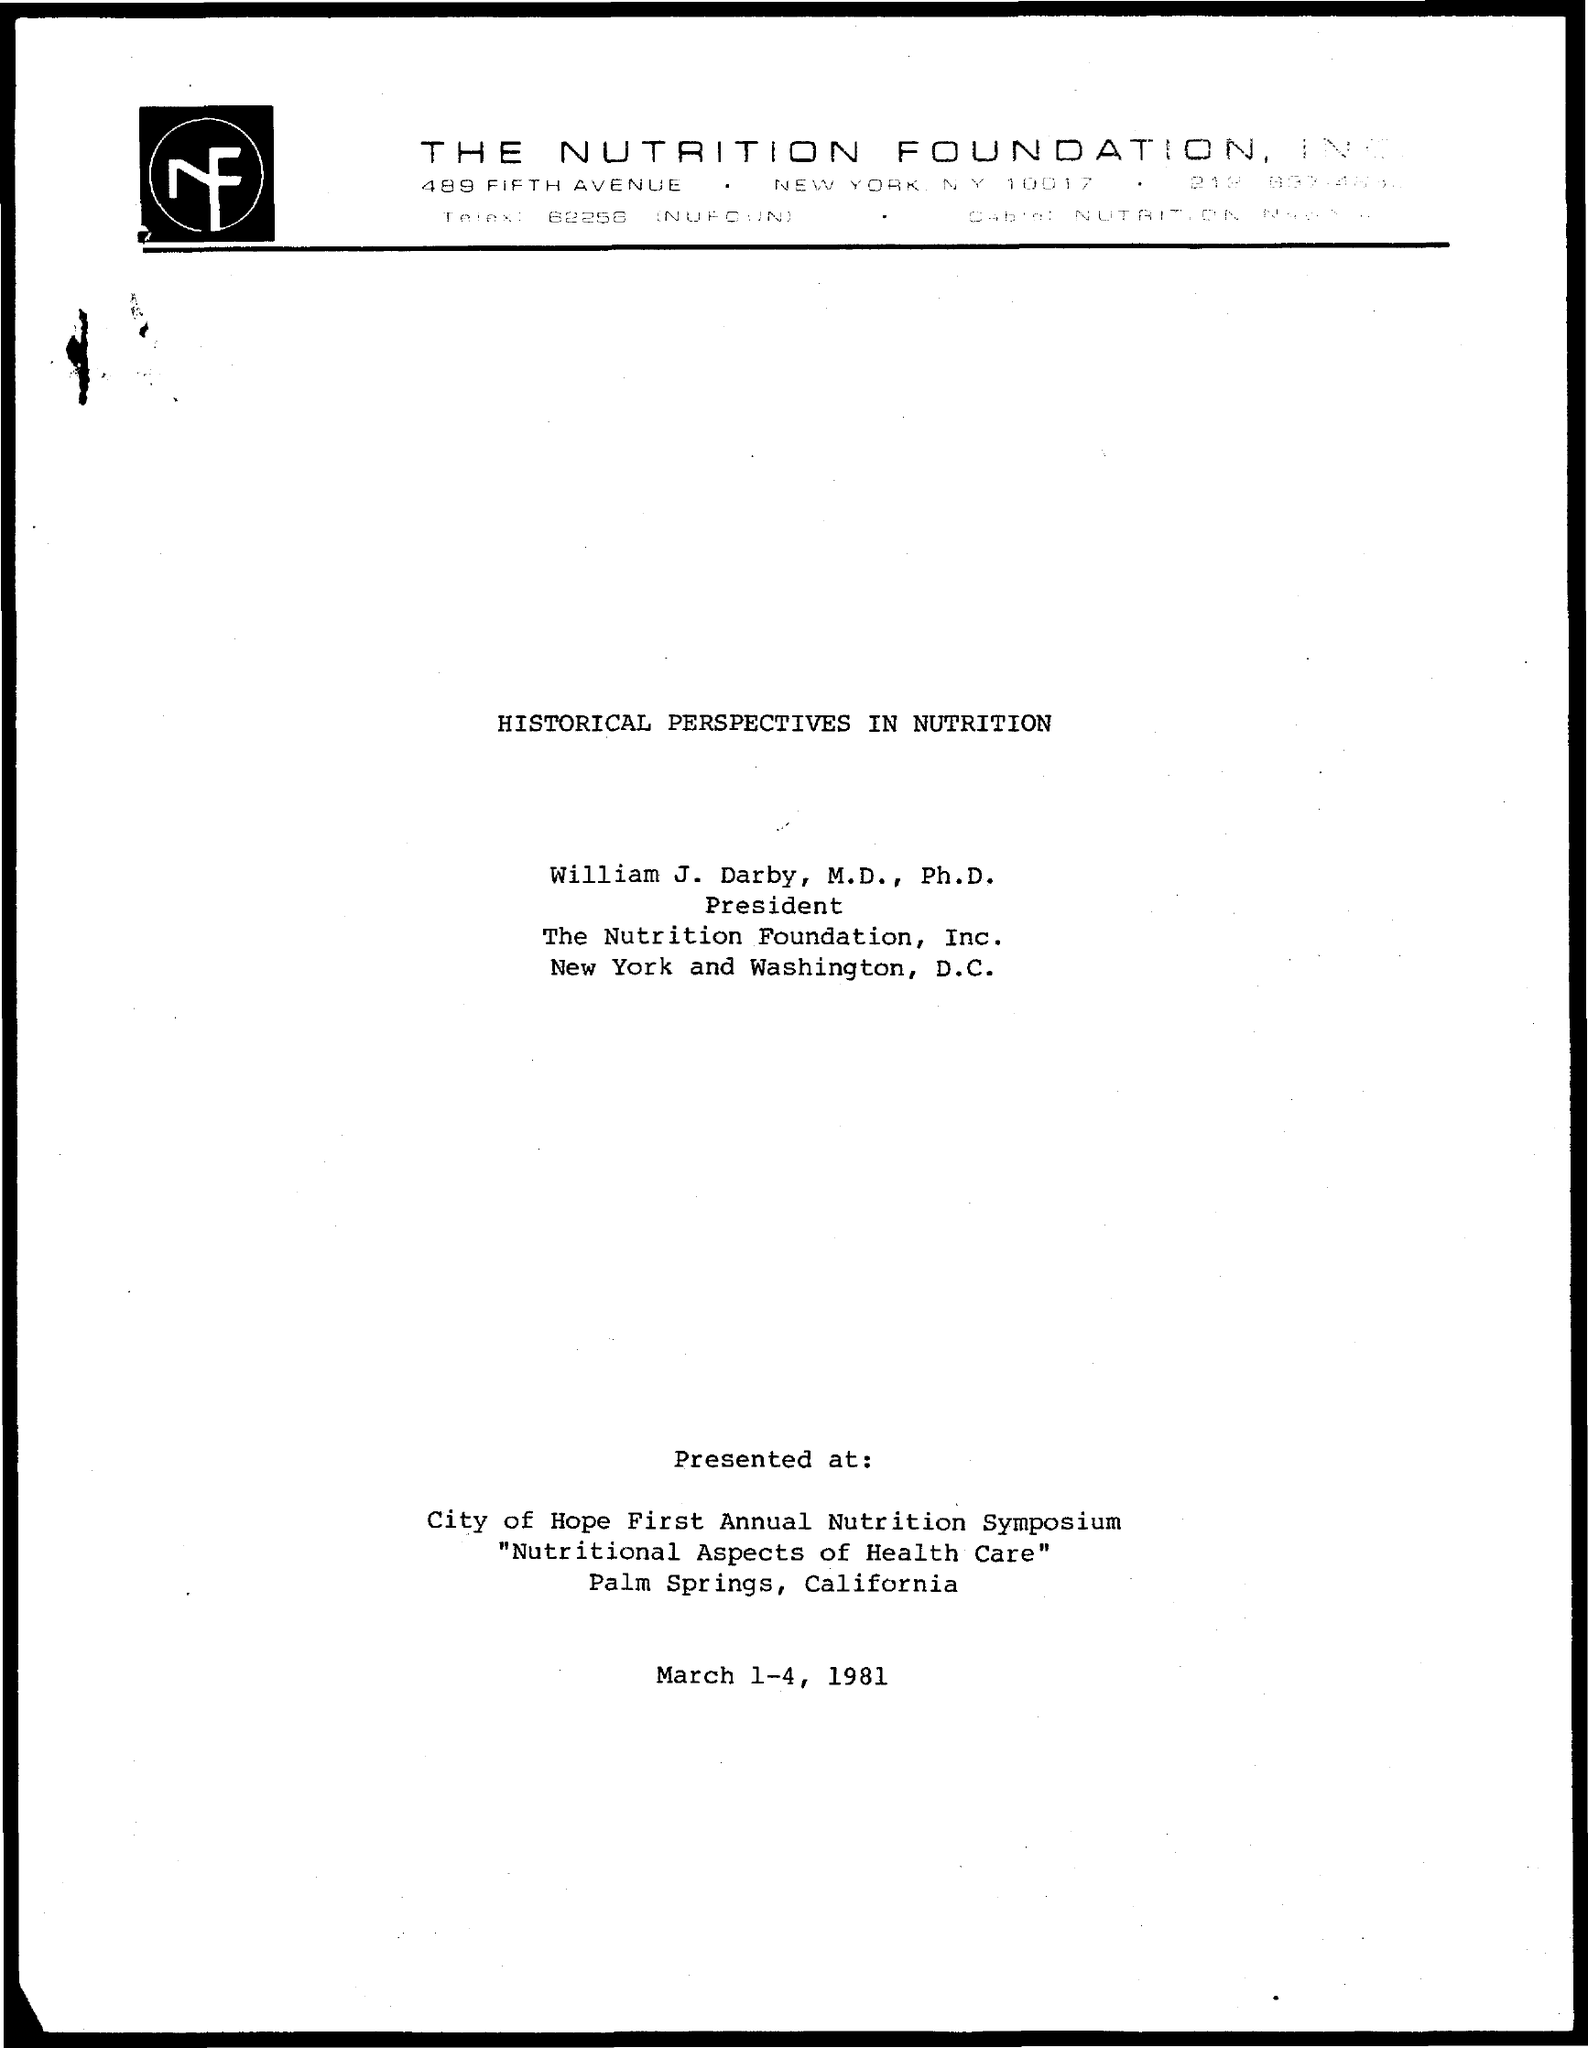What is the Title of the document?
Your answer should be compact. Historical Perspectives in Nutrition. Who is the president?
Ensure brevity in your answer.  William J. Darby, M.D., Ph.D. 